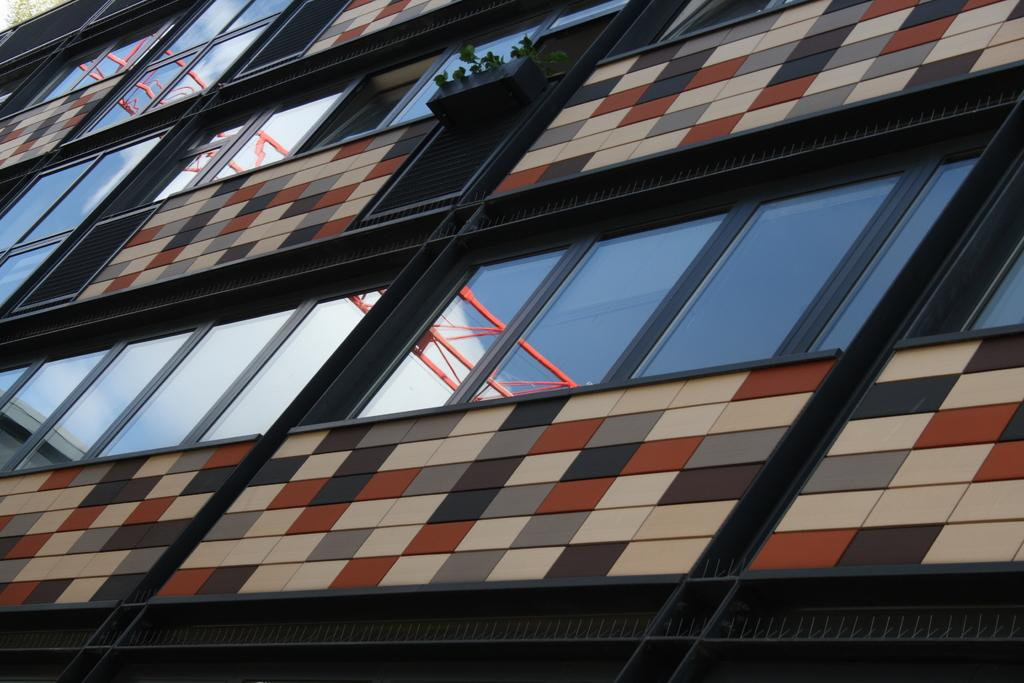What is the main subject of the image? The main subject of the image is a building. Can you describe any specific features of the building? Yes, there are glass windows visible in the image. What type of powder can be seen covering the building in the image? There is no powder visible on the building in the image. Can you see a toad sitting on the glass windows in the image? There is no toad present in the image. 